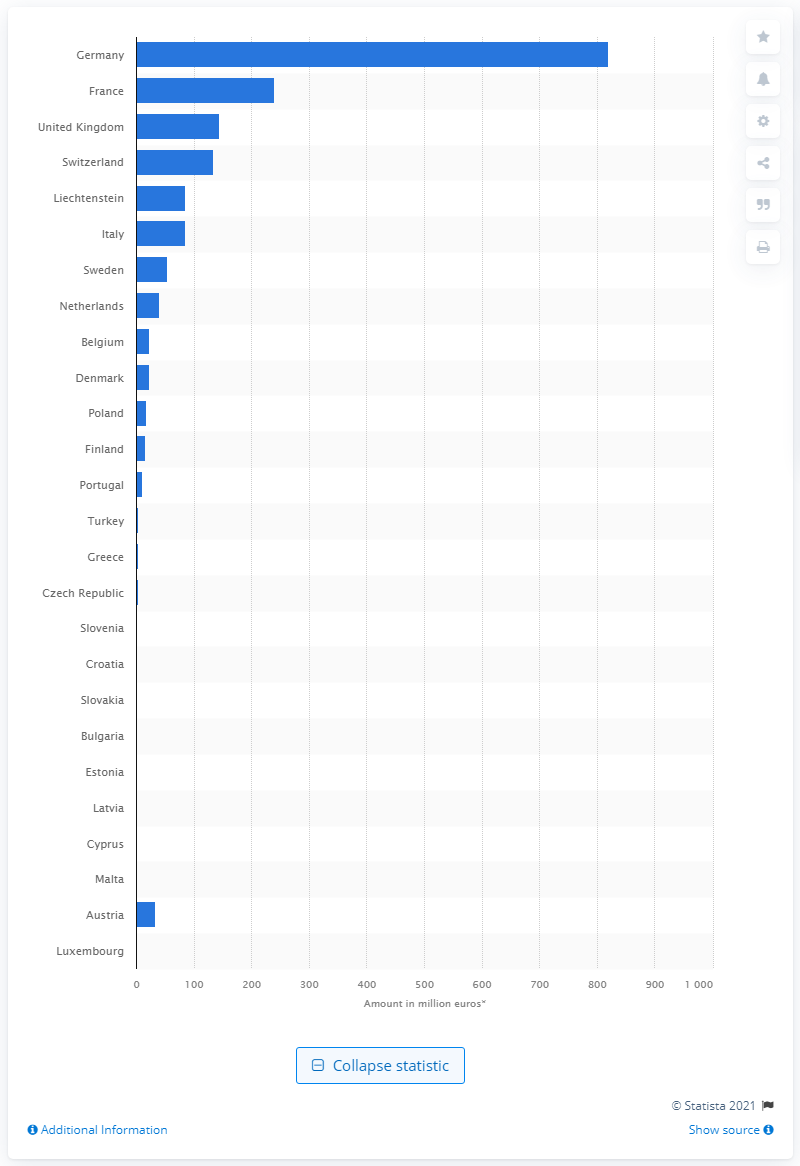Give some essential details in this illustration. The investment portfolio of non-life insurers operating in Germany in 2018 was 819.51. 